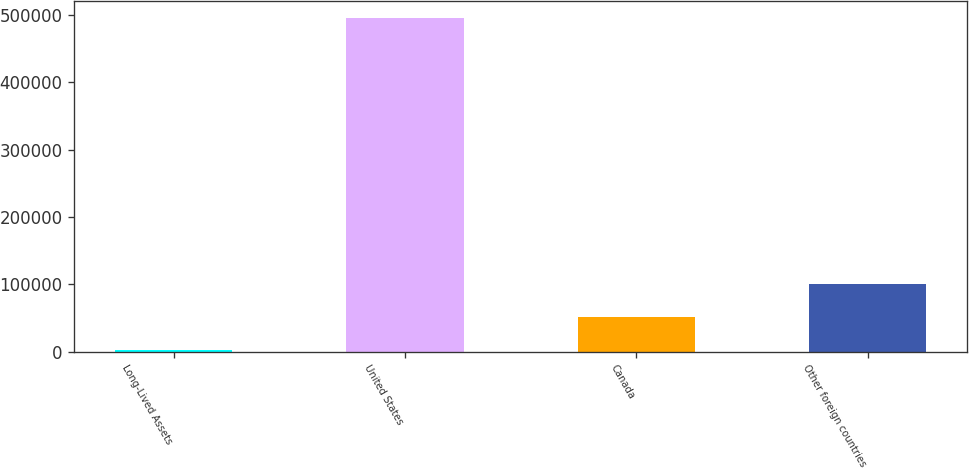<chart> <loc_0><loc_0><loc_500><loc_500><bar_chart><fcel>Long-Lived Assets<fcel>United States<fcel>Canada<fcel>Other foreign countries<nl><fcel>2012<fcel>495609<fcel>51371.7<fcel>100731<nl></chart> 